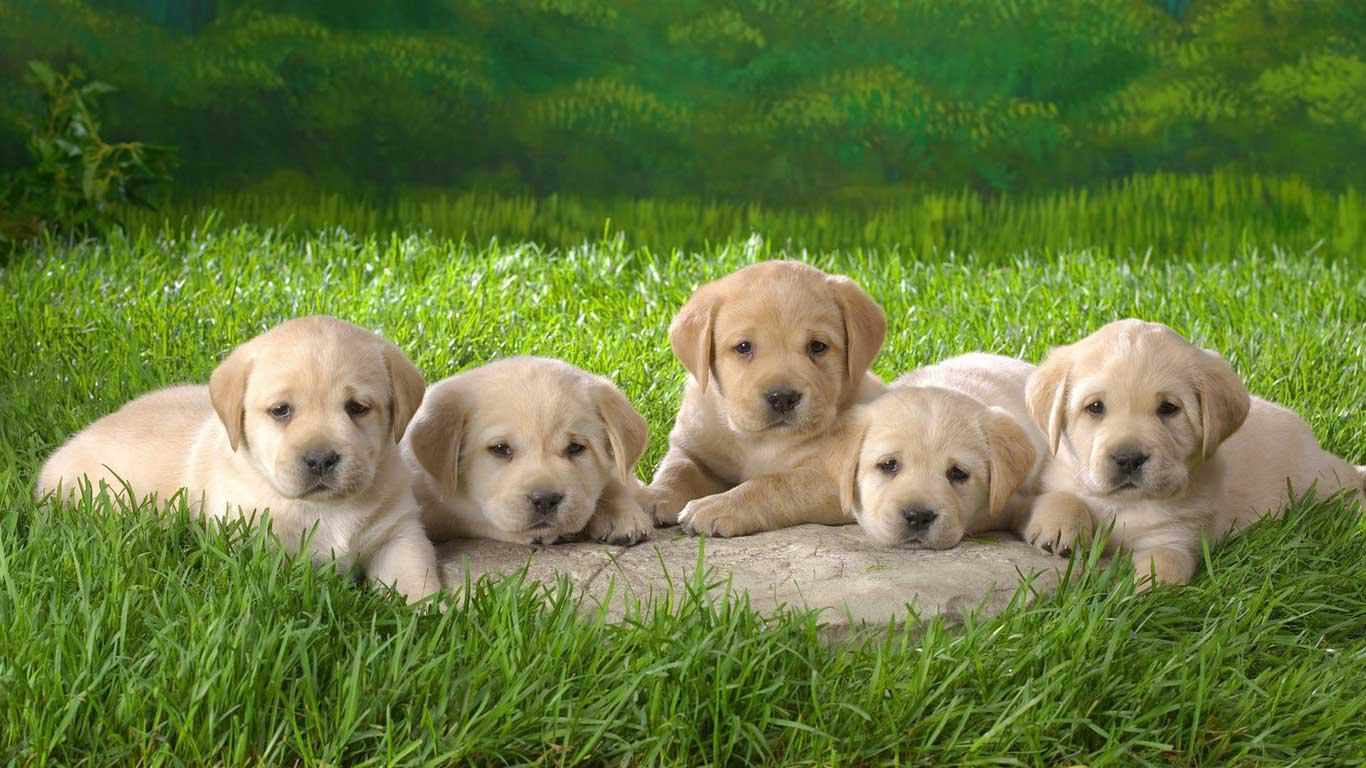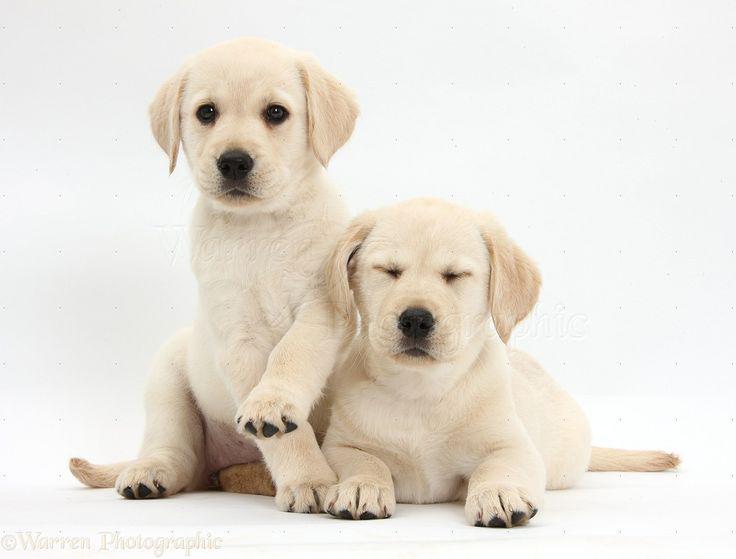The first image is the image on the left, the second image is the image on the right. Considering the images on both sides, is "Exactly seven dogs are shown, in groups of two and five." valid? Answer yes or no. Yes. The first image is the image on the left, the second image is the image on the right. Given the left and right images, does the statement "One image shows a group of five sitting and reclining puppies in an indoor setting." hold true? Answer yes or no. No. 